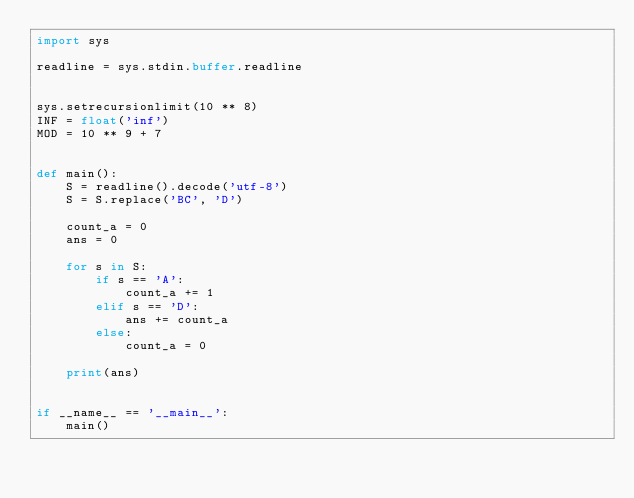<code> <loc_0><loc_0><loc_500><loc_500><_Python_>import sys

readline = sys.stdin.buffer.readline


sys.setrecursionlimit(10 ** 8)
INF = float('inf')
MOD = 10 ** 9 + 7


def main():
    S = readline().decode('utf-8')
    S = S.replace('BC', 'D')

    count_a = 0
    ans = 0

    for s in S:
        if s == 'A':
            count_a += 1
        elif s == 'D':
            ans += count_a
        else:
            count_a = 0

    print(ans)


if __name__ == '__main__':
    main()
</code> 